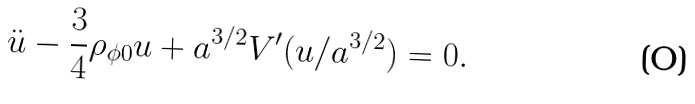<formula> <loc_0><loc_0><loc_500><loc_500>\ddot { u } - \frac { 3 } { 4 } \rho _ { \phi 0 } u + a ^ { 3 / 2 } V ^ { \prime } ( u / a ^ { 3 / 2 } ) = 0 .</formula> 